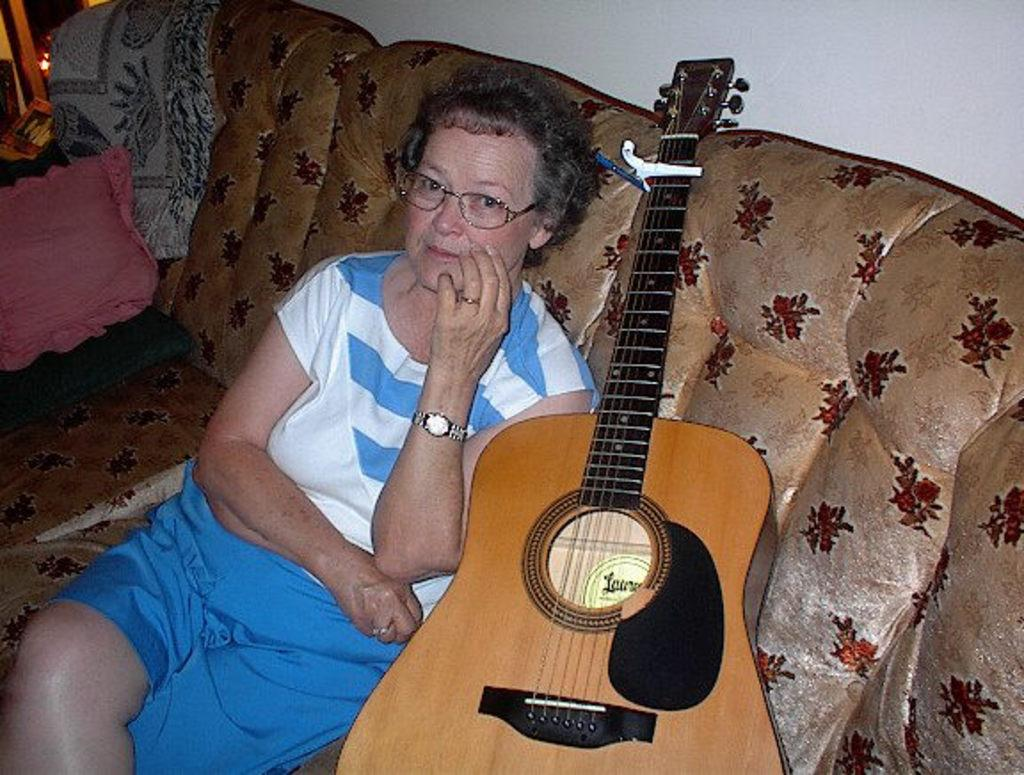Who is the main subject in the image? There is a lady in the image. What is the lady wearing? The lady is wearing a blue and white dress. Are there any accessories visible on the lady? Yes, the lady is wearing a watch and spectacles. What is the lady's position in the image? The lady is sitting on a sofa. What object is near the lady? There is a guitar near the lady. What is visible behind the lady? There is a wall behind the lady. What type of business is the lady conducting in the image? There is no indication of any business activity in the image. How does the taste of the guitar contribute to the overall atmosphere of the image? The image does not depict any taste or flavor, and the guitar is an inanimate object, so it cannot have a taste. 